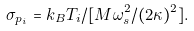Convert formula to latex. <formula><loc_0><loc_0><loc_500><loc_500>\sigma _ { p _ { i } } = k _ { B } T _ { i } / [ M \omega _ { s } ^ { 2 } / ( 2 \kappa ) ^ { 2 } ] .</formula> 